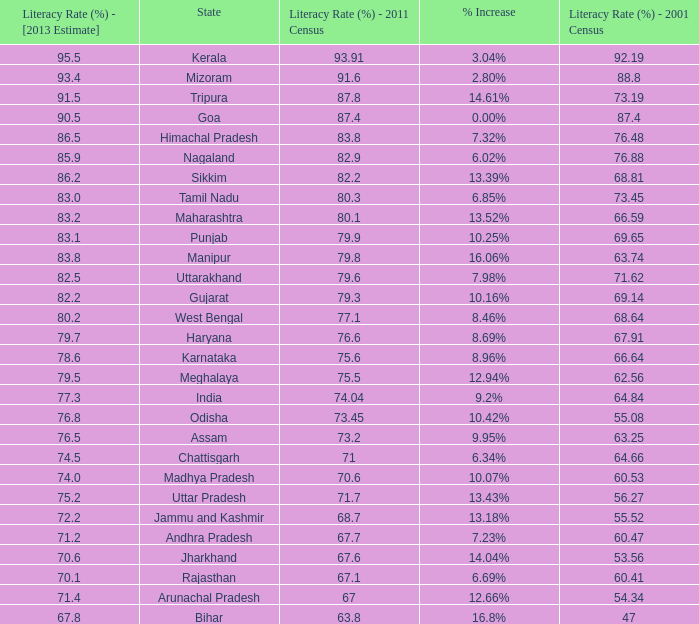What is the average estimated 2013 literacy rate for the states that had a literacy rate of 68.81% in the 2001 census and a literacy rate higher than 79.6% in the 2011 census? 86.2. 